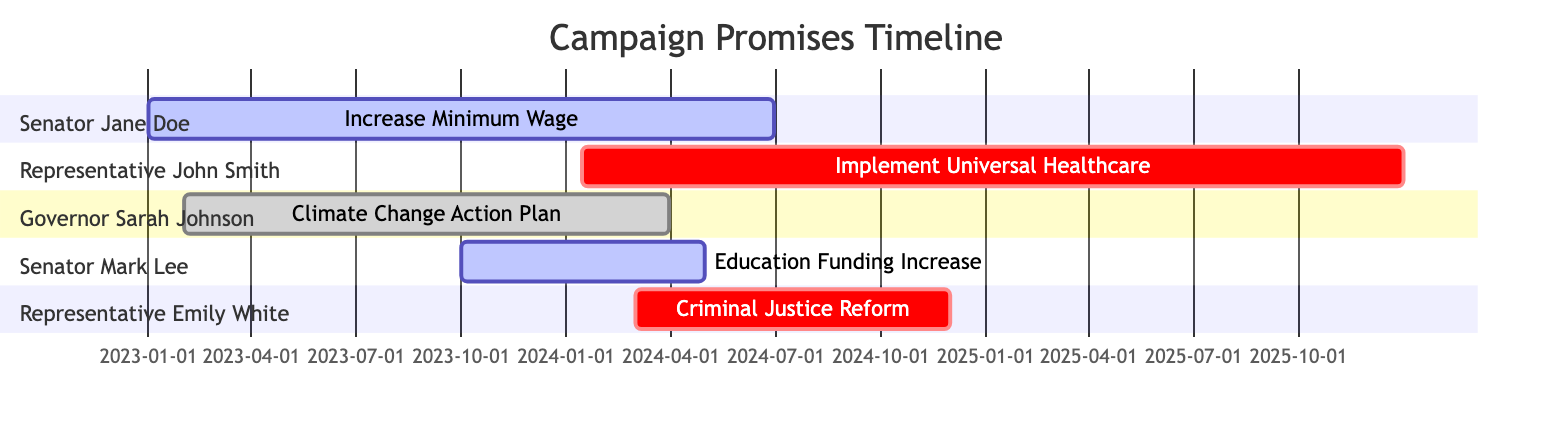What is the deadline for the "Increase Minimum Wage" promise? The deadline for the "Increase Minimum Wage" promise is specifically stated as June 30, 2024, in the information provided.
Answer: June 30, 2024 Which legislator is associated with the "Climate Change Action Plan"? The diagram indicates that Governor Sarah Johnson is the legislator associated with the "Climate Change Action Plan."
Answer: Governor Sarah Johnson How many promises are currently in progress? By examining the diagram, two promises—"Increase Minimum Wage" and "Education Funding Increase"—are identified as in progress.
Answer: 2 What is the completion date for the "Climate Change Action Plan"? The diagram displays the completion date for the "Climate Change Action Plan" as March 30, 2024.
Answer: March 30, 2024 What is the status of "Criminal Justice Reform"? The diagram indicates that "Criminal Justice Reform" is labeled as proposed, showing that it has not been implemented yet.
Answer: Proposed What is the difference in deadlines between "Implement Universal Healthcare" and "Education Funding Increase"? The deadline for "Implement Universal Healthcare" is December 31, 2025, while for "Education Funding Increase" it is May 1, 2024. The difference between these two deadlines is calculated as 1 year and approximately 7 months apart.
Answer: 1 year and 7 months Which promise has the longest duration from start to deadline? By analyzing the start and deadline dates, "Implement Universal Healthcare" has the longest duration from January 15, 2024, to December 31, 2025, yielding a total duration of approximately 1 year and 11.5 months.
Answer: Implement Universal Healthcare How many legislators are involved in total? The diagram shows four different legislators across various promises: Senator Jane Doe, Representative John Smith, Governor Sarah Johnson, Senator Mark Lee, and Representative Emily White, indicating a total of five legislators involved.
Answer: 5 What is the status of the program that has its completion date already noted? The program "Climate Change Action Plan" has a noted completion date, and its status is completed.
Answer: Completed What promise has the earliest start date? By reviewing the start dates, "Increase Minimum Wage" has the earliest start date of January 1, 2023.
Answer: Increase Minimum Wage 